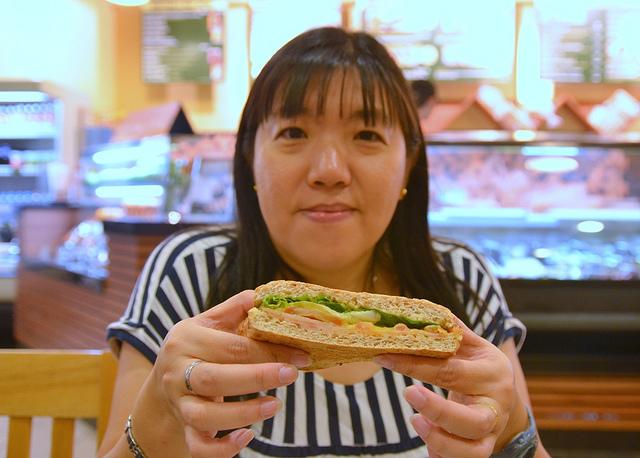Is this in someone's home?
Give a very brief answer. No. Does the sandwich have lettuce?
Keep it brief. Yes. What ethnicity is the woman?
Answer briefly. Asian. 